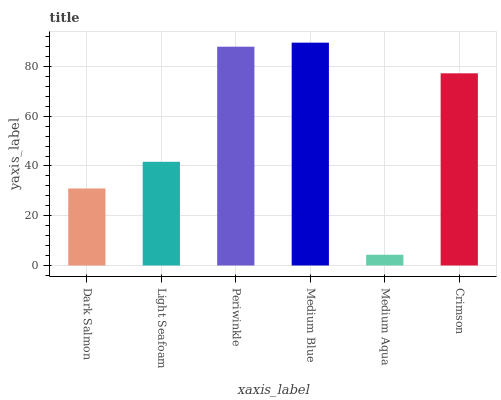Is Light Seafoam the minimum?
Answer yes or no. No. Is Light Seafoam the maximum?
Answer yes or no. No. Is Light Seafoam greater than Dark Salmon?
Answer yes or no. Yes. Is Dark Salmon less than Light Seafoam?
Answer yes or no. Yes. Is Dark Salmon greater than Light Seafoam?
Answer yes or no. No. Is Light Seafoam less than Dark Salmon?
Answer yes or no. No. Is Crimson the high median?
Answer yes or no. Yes. Is Light Seafoam the low median?
Answer yes or no. Yes. Is Dark Salmon the high median?
Answer yes or no. No. Is Medium Aqua the low median?
Answer yes or no. No. 